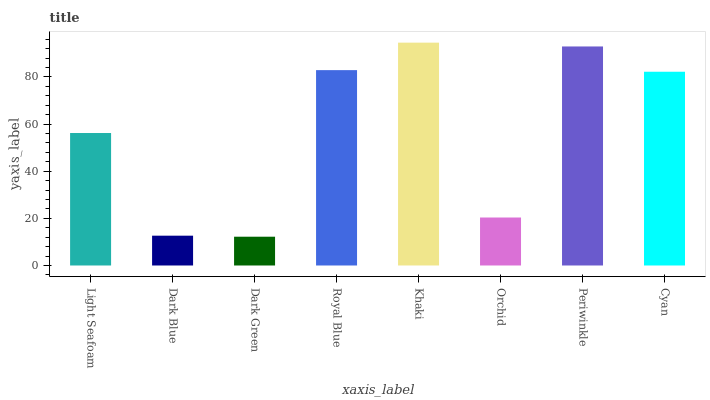Is Dark Green the minimum?
Answer yes or no. Yes. Is Khaki the maximum?
Answer yes or no. Yes. Is Dark Blue the minimum?
Answer yes or no. No. Is Dark Blue the maximum?
Answer yes or no. No. Is Light Seafoam greater than Dark Blue?
Answer yes or no. Yes. Is Dark Blue less than Light Seafoam?
Answer yes or no. Yes. Is Dark Blue greater than Light Seafoam?
Answer yes or no. No. Is Light Seafoam less than Dark Blue?
Answer yes or no. No. Is Cyan the high median?
Answer yes or no. Yes. Is Light Seafoam the low median?
Answer yes or no. Yes. Is Periwinkle the high median?
Answer yes or no. No. Is Khaki the low median?
Answer yes or no. No. 